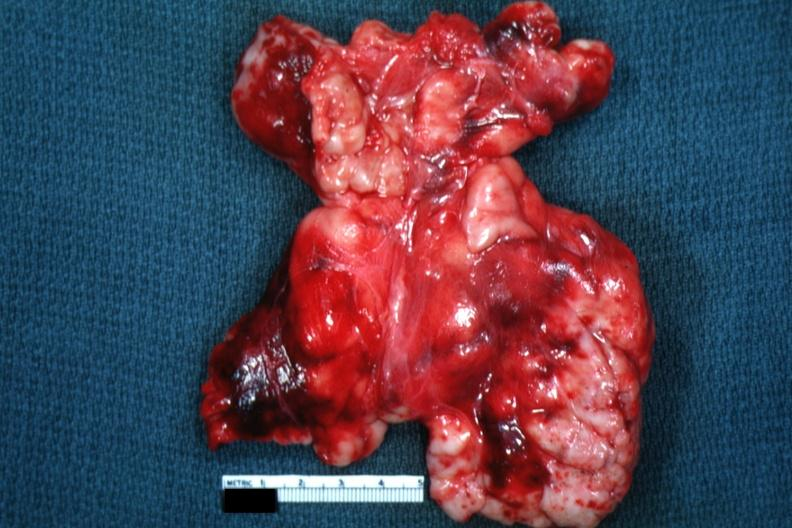does this image appear as large mass of matted nodes like malignant lymphoma?
Answer the question using a single word or phrase. Yes 